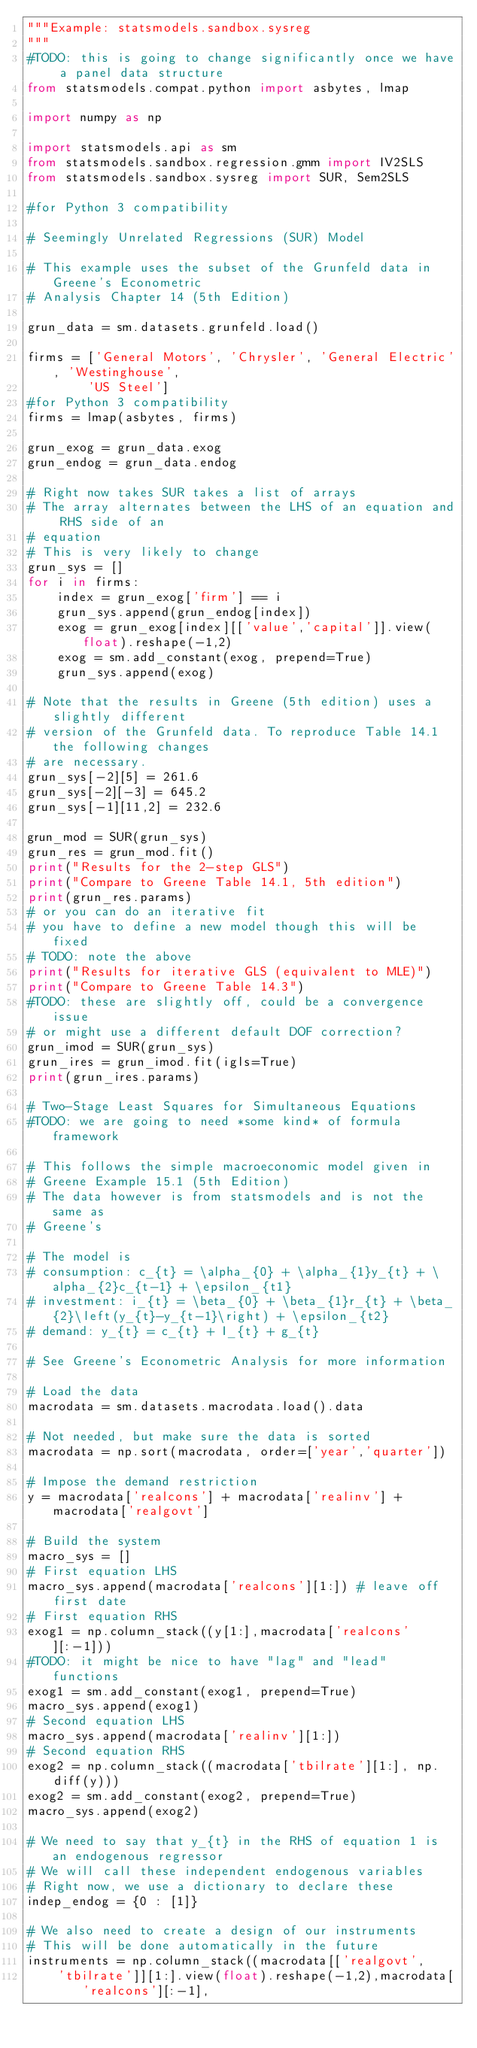Convert code to text. <code><loc_0><loc_0><loc_500><loc_500><_Python_>"""Example: statsmodels.sandbox.sysreg
"""
#TODO: this is going to change significantly once we have a panel data structure
from statsmodels.compat.python import asbytes, lmap

import numpy as np

import statsmodels.api as sm
from statsmodels.sandbox.regression.gmm import IV2SLS
from statsmodels.sandbox.sysreg import SUR, Sem2SLS

#for Python 3 compatibility

# Seemingly Unrelated Regressions (SUR) Model

# This example uses the subset of the Grunfeld data in Greene's Econometric
# Analysis Chapter 14 (5th Edition)

grun_data = sm.datasets.grunfeld.load()

firms = ['General Motors', 'Chrysler', 'General Electric', 'Westinghouse',
        'US Steel']
#for Python 3 compatibility
firms = lmap(asbytes, firms)

grun_exog = grun_data.exog
grun_endog = grun_data.endog

# Right now takes SUR takes a list of arrays
# The array alternates between the LHS of an equation and RHS side of an
# equation
# This is very likely to change
grun_sys = []
for i in firms:
    index = grun_exog['firm'] == i
    grun_sys.append(grun_endog[index])
    exog = grun_exog[index][['value','capital']].view(float).reshape(-1,2)
    exog = sm.add_constant(exog, prepend=True)
    grun_sys.append(exog)

# Note that the results in Greene (5th edition) uses a slightly different
# version of the Grunfeld data. To reproduce Table 14.1 the following changes
# are necessary.
grun_sys[-2][5] = 261.6
grun_sys[-2][-3] = 645.2
grun_sys[-1][11,2] = 232.6

grun_mod = SUR(grun_sys)
grun_res = grun_mod.fit()
print("Results for the 2-step GLS")
print("Compare to Greene Table 14.1, 5th edition")
print(grun_res.params)
# or you can do an iterative fit
# you have to define a new model though this will be fixed
# TODO: note the above
print("Results for iterative GLS (equivalent to MLE)")
print("Compare to Greene Table 14.3")
#TODO: these are slightly off, could be a convergence issue
# or might use a different default DOF correction?
grun_imod = SUR(grun_sys)
grun_ires = grun_imod.fit(igls=True)
print(grun_ires.params)

# Two-Stage Least Squares for Simultaneous Equations
#TODO: we are going to need *some kind* of formula framework

# This follows the simple macroeconomic model given in
# Greene Example 15.1 (5th Edition)
# The data however is from statsmodels and is not the same as
# Greene's

# The model is
# consumption: c_{t} = \alpha_{0} + \alpha_{1}y_{t} + \alpha_{2}c_{t-1} + \epsilon_{t1}
# investment: i_{t} = \beta_{0} + \beta_{1}r_{t} + \beta_{2}\left(y_{t}-y_{t-1}\right) + \epsilon_{t2}
# demand: y_{t} = c_{t} + I_{t} + g_{t}

# See Greene's Econometric Analysis for more information

# Load the data
macrodata = sm.datasets.macrodata.load().data

# Not needed, but make sure the data is sorted
macrodata = np.sort(macrodata, order=['year','quarter'])

# Impose the demand restriction
y = macrodata['realcons'] + macrodata['realinv'] + macrodata['realgovt']

# Build the system
macro_sys = []
# First equation LHS
macro_sys.append(macrodata['realcons'][1:]) # leave off first date
# First equation RHS
exog1 = np.column_stack((y[1:],macrodata['realcons'][:-1]))
#TODO: it might be nice to have "lag" and "lead" functions
exog1 = sm.add_constant(exog1, prepend=True)
macro_sys.append(exog1)
# Second equation LHS
macro_sys.append(macrodata['realinv'][1:])
# Second equation RHS
exog2 = np.column_stack((macrodata['tbilrate'][1:], np.diff(y)))
exog2 = sm.add_constant(exog2, prepend=True)
macro_sys.append(exog2)

# We need to say that y_{t} in the RHS of equation 1 is an endogenous regressor
# We will call these independent endogenous variables
# Right now, we use a dictionary to declare these
indep_endog = {0 : [1]}

# We also need to create a design of our instruments
# This will be done automatically in the future
instruments = np.column_stack((macrodata[['realgovt',
    'tbilrate']][1:].view(float).reshape(-1,2),macrodata['realcons'][:-1],</code> 